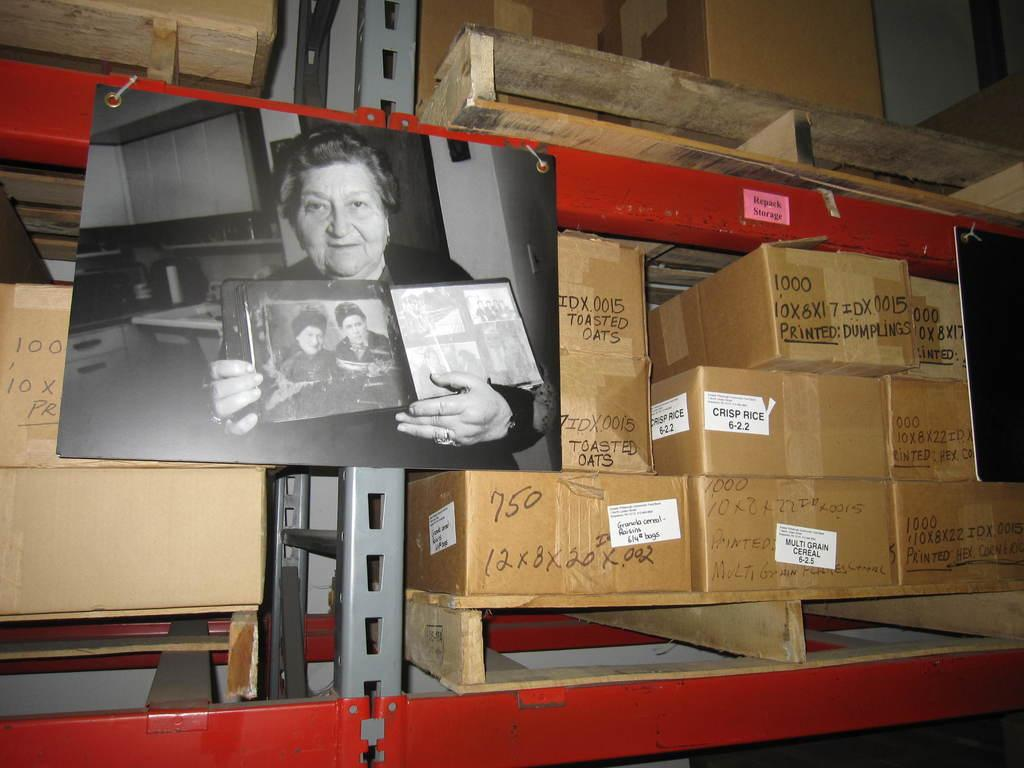<image>
Relay a brief, clear account of the picture shown. The first box to the right of the photo contains toasted oats. 